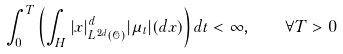<formula> <loc_0><loc_0><loc_500><loc_500>\int _ { 0 } ^ { T } \left ( \int _ { H } | x | _ { L ^ { 2 d } ( \mathcal { O } ) } ^ { d } | \mu _ { t } | ( d x ) \right ) d t < \infty , \quad \forall T > 0</formula> 